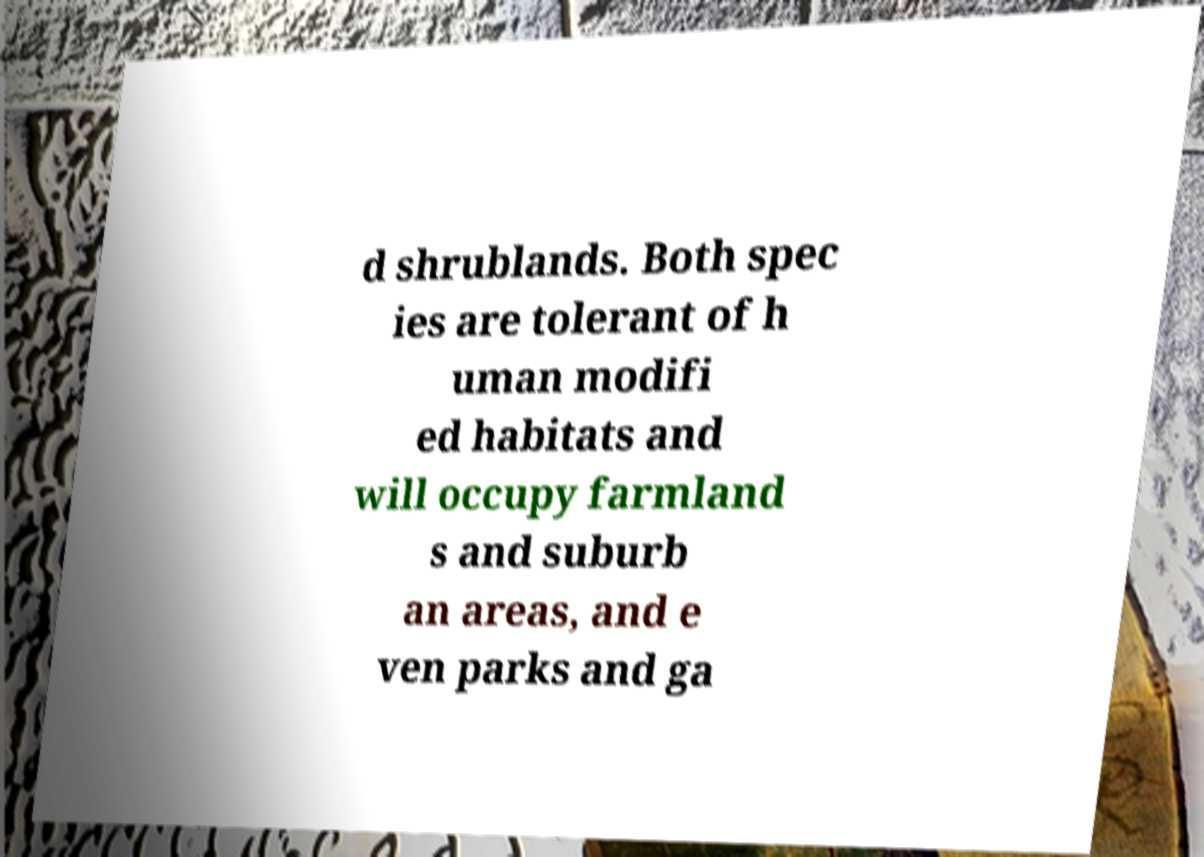Please identify and transcribe the text found in this image. d shrublands. Both spec ies are tolerant of h uman modifi ed habitats and will occupy farmland s and suburb an areas, and e ven parks and ga 